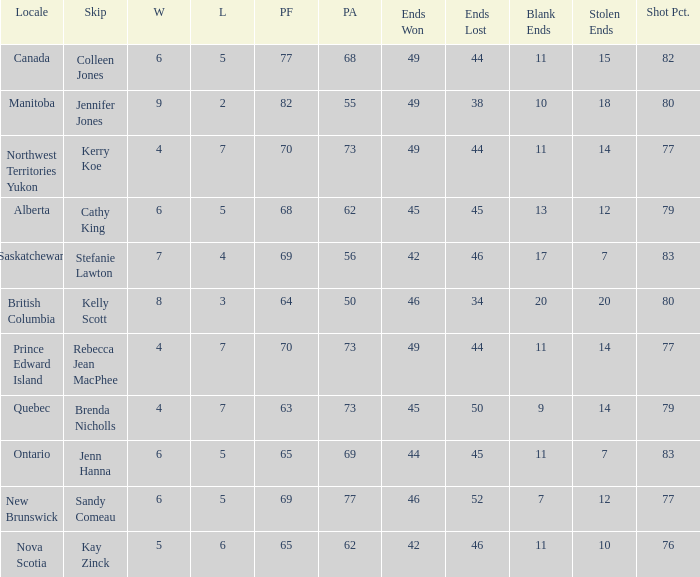What is the total number of ends won when the locale is Northwest Territories Yukon? 1.0. 